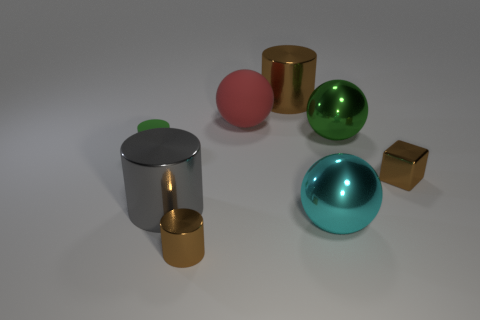What color is the big matte ball?
Provide a succinct answer. Red. Is there any other thing that has the same material as the green ball?
Offer a very short reply. Yes. What is the shape of the green object right of the big cyan sphere?
Provide a succinct answer. Sphere. There is a brown object behind the object on the right side of the large green sphere; is there a large red rubber object in front of it?
Ensure brevity in your answer.  Yes. Are there any other things that are the same shape as the big cyan metallic thing?
Offer a terse response. Yes. Are there any green metallic balls?
Ensure brevity in your answer.  Yes. Are the cyan ball to the right of the small green thing and the brown cylinder in front of the large brown shiny thing made of the same material?
Your answer should be very brief. Yes. There is a brown cylinder in front of the large cylinder behind the small brown shiny object behind the cyan thing; what is its size?
Your answer should be very brief. Small. What number of red blocks are the same material as the big cyan sphere?
Your answer should be very brief. 0. Is the number of green rubber spheres less than the number of brown things?
Ensure brevity in your answer.  Yes. 